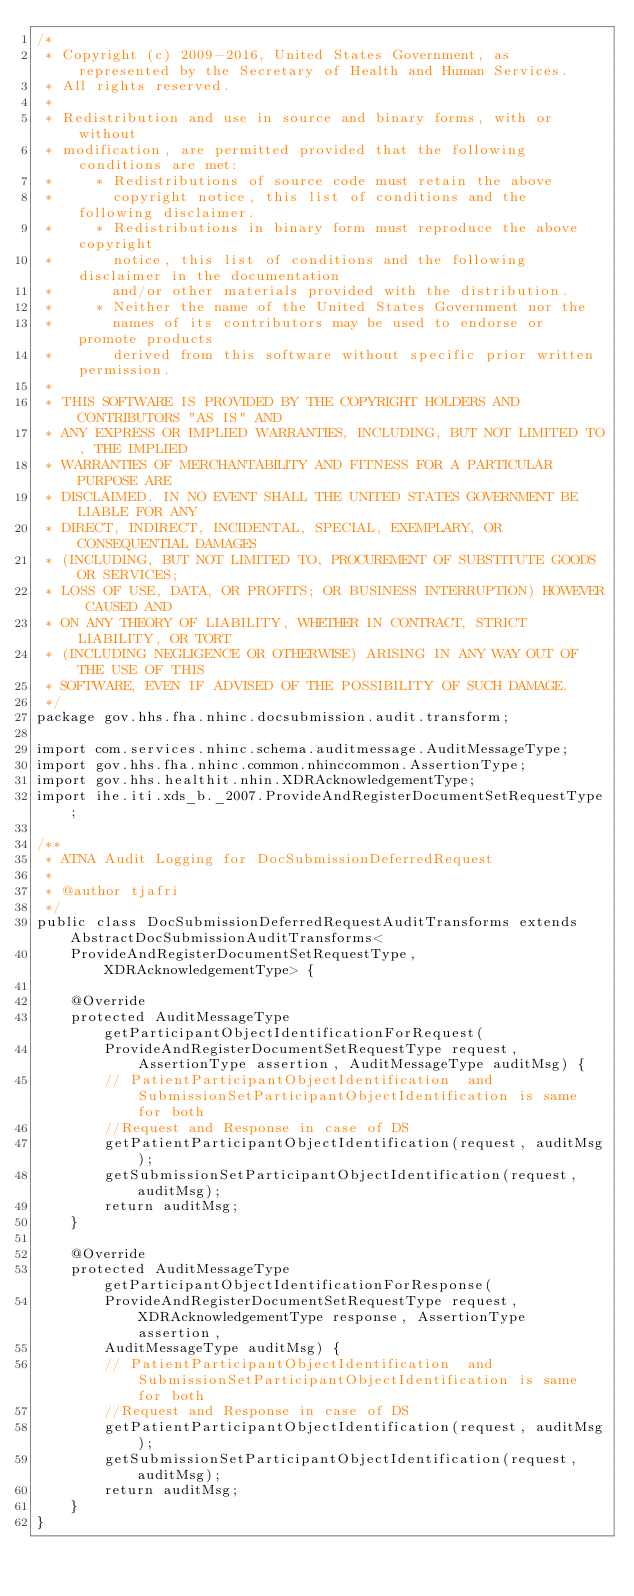<code> <loc_0><loc_0><loc_500><loc_500><_Java_>/*
 * Copyright (c) 2009-2016, United States Government, as represented by the Secretary of Health and Human Services.
 * All rights reserved.
 *
 * Redistribution and use in source and binary forms, with or without
 * modification, are permitted provided that the following conditions are met:
 *     * Redistributions of source code must retain the above
 *       copyright notice, this list of conditions and the following disclaimer.
 *     * Redistributions in binary form must reproduce the above copyright
 *       notice, this list of conditions and the following disclaimer in the documentation
 *       and/or other materials provided with the distribution.
 *     * Neither the name of the United States Government nor the
 *       names of its contributors may be used to endorse or promote products
 *       derived from this software without specific prior written permission.
 *
 * THIS SOFTWARE IS PROVIDED BY THE COPYRIGHT HOLDERS AND CONTRIBUTORS "AS IS" AND
 * ANY EXPRESS OR IMPLIED WARRANTIES, INCLUDING, BUT NOT LIMITED TO, THE IMPLIED
 * WARRANTIES OF MERCHANTABILITY AND FITNESS FOR A PARTICULAR PURPOSE ARE
 * DISCLAIMED. IN NO EVENT SHALL THE UNITED STATES GOVERNMENT BE LIABLE FOR ANY
 * DIRECT, INDIRECT, INCIDENTAL, SPECIAL, EXEMPLARY, OR CONSEQUENTIAL DAMAGES
 * (INCLUDING, BUT NOT LIMITED TO, PROCUREMENT OF SUBSTITUTE GOODS OR SERVICES;
 * LOSS OF USE, DATA, OR PROFITS; OR BUSINESS INTERRUPTION) HOWEVER CAUSED AND
 * ON ANY THEORY OF LIABILITY, WHETHER IN CONTRACT, STRICT LIABILITY, OR TORT
 * (INCLUDING NEGLIGENCE OR OTHERWISE) ARISING IN ANY WAY OUT OF THE USE OF THIS
 * SOFTWARE, EVEN IF ADVISED OF THE POSSIBILITY OF SUCH DAMAGE.
 */
package gov.hhs.fha.nhinc.docsubmission.audit.transform;

import com.services.nhinc.schema.auditmessage.AuditMessageType;
import gov.hhs.fha.nhinc.common.nhinccommon.AssertionType;
import gov.hhs.healthit.nhin.XDRAcknowledgementType;
import ihe.iti.xds_b._2007.ProvideAndRegisterDocumentSetRequestType;

/**
 * ATNA Audit Logging for DocSubmissionDeferredRequest
 *
 * @author tjafri
 */
public class DocSubmissionDeferredRequestAuditTransforms extends AbstractDocSubmissionAuditTransforms<
    ProvideAndRegisterDocumentSetRequestType, XDRAcknowledgementType> {

    @Override
    protected AuditMessageType getParticipantObjectIdentificationForRequest(
        ProvideAndRegisterDocumentSetRequestType request, AssertionType assertion, AuditMessageType auditMsg) {
        // PatientParticipantObjectIdentification  and SubmissionSetParticipantObjectIdentification is same for both
        //Request and Response in case of DS
        getPatientParticipantObjectIdentification(request, auditMsg);
        getSubmissionSetParticipantObjectIdentification(request, auditMsg);
        return auditMsg;
    }

    @Override
    protected AuditMessageType getParticipantObjectIdentificationForResponse(
        ProvideAndRegisterDocumentSetRequestType request, XDRAcknowledgementType response, AssertionType assertion,
        AuditMessageType auditMsg) {
        // PatientParticipantObjectIdentification  and SubmissionSetParticipantObjectIdentification is same for both
        //Request and Response in case of DS
        getPatientParticipantObjectIdentification(request, auditMsg);
        getSubmissionSetParticipantObjectIdentification(request, auditMsg);
        return auditMsg;
    }
}
</code> 